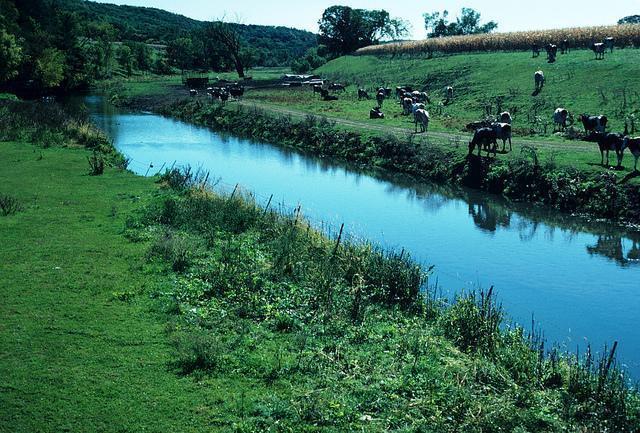How many people are on the stairs in the picture?
Give a very brief answer. 0. 